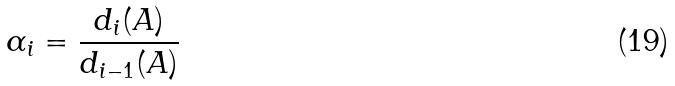<formula> <loc_0><loc_0><loc_500><loc_500>\alpha _ { i } = \frac { d _ { i } ( A ) } { d _ { i - 1 } ( A ) }</formula> 